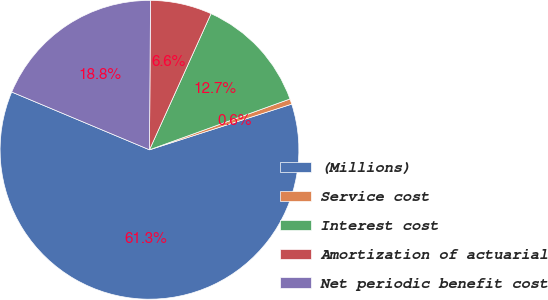Convert chart. <chart><loc_0><loc_0><loc_500><loc_500><pie_chart><fcel>(Millions)<fcel>Service cost<fcel>Interest cost<fcel>Amortization of actuarial<fcel>Net periodic benefit cost<nl><fcel>61.27%<fcel>0.58%<fcel>12.72%<fcel>6.65%<fcel>18.79%<nl></chart> 